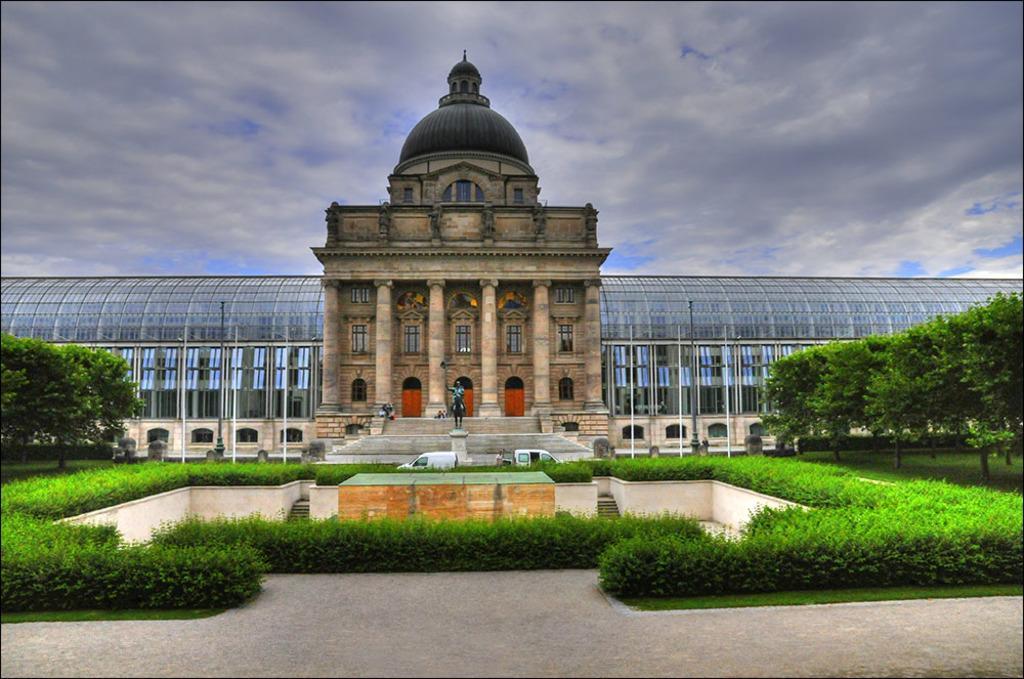Can you describe this image briefly? In this picture we can see a statue on the pillar. Behind the statue there are vehicle, poles, a building and the sky. On the left and right side of the statue there are trees, plants and grass. 